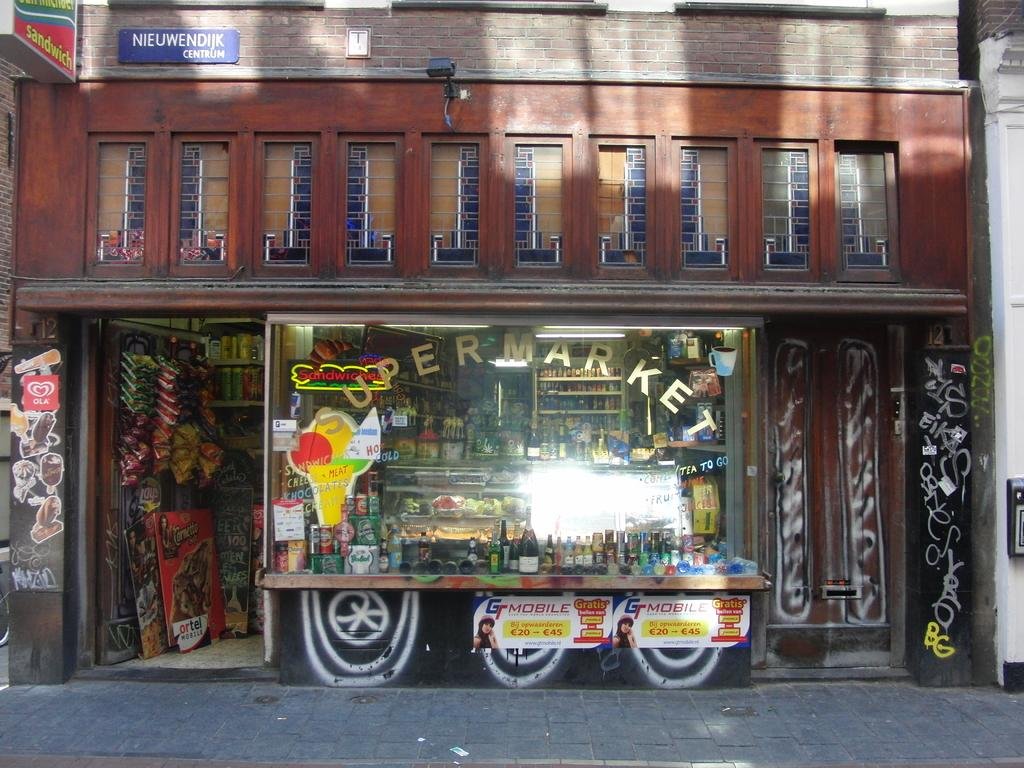What type of establishment is depicted in the image? The image is of a store. What items can be seen inside the store? There are bottles, boards, food packets, and various things visible in the image. How are the items organized in the store? There are racks in the image, which suggests that the items are organized on shelves or displays. What is present on the exterior of the store? There is a hoarding in the image, which may display advertisements or information about the store. Is there any writing visible on the store's exterior? Yes, there is something written on the glass window of the store. Where is the mailbox located in the image? There is no mailbox present in the image. What type of pan is being used to cook food in the image? There is no pan or cooking activity depicted in the image. 